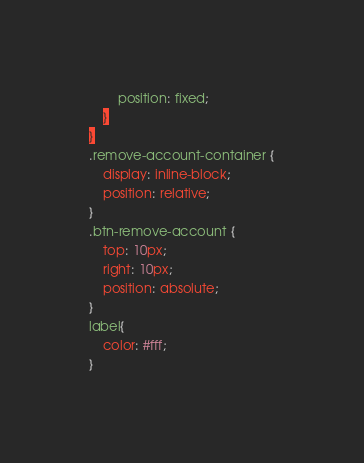Convert code to text. <code><loc_0><loc_0><loc_500><loc_500><_CSS_>		position: fixed;
	}
}
.remove-account-container {
	display: inline-block;
	position: relative;
}
.btn-remove-account {
	top: 10px;
	right: 10px;
	position: absolute;
}
label{
	color: #fff;
}</code> 